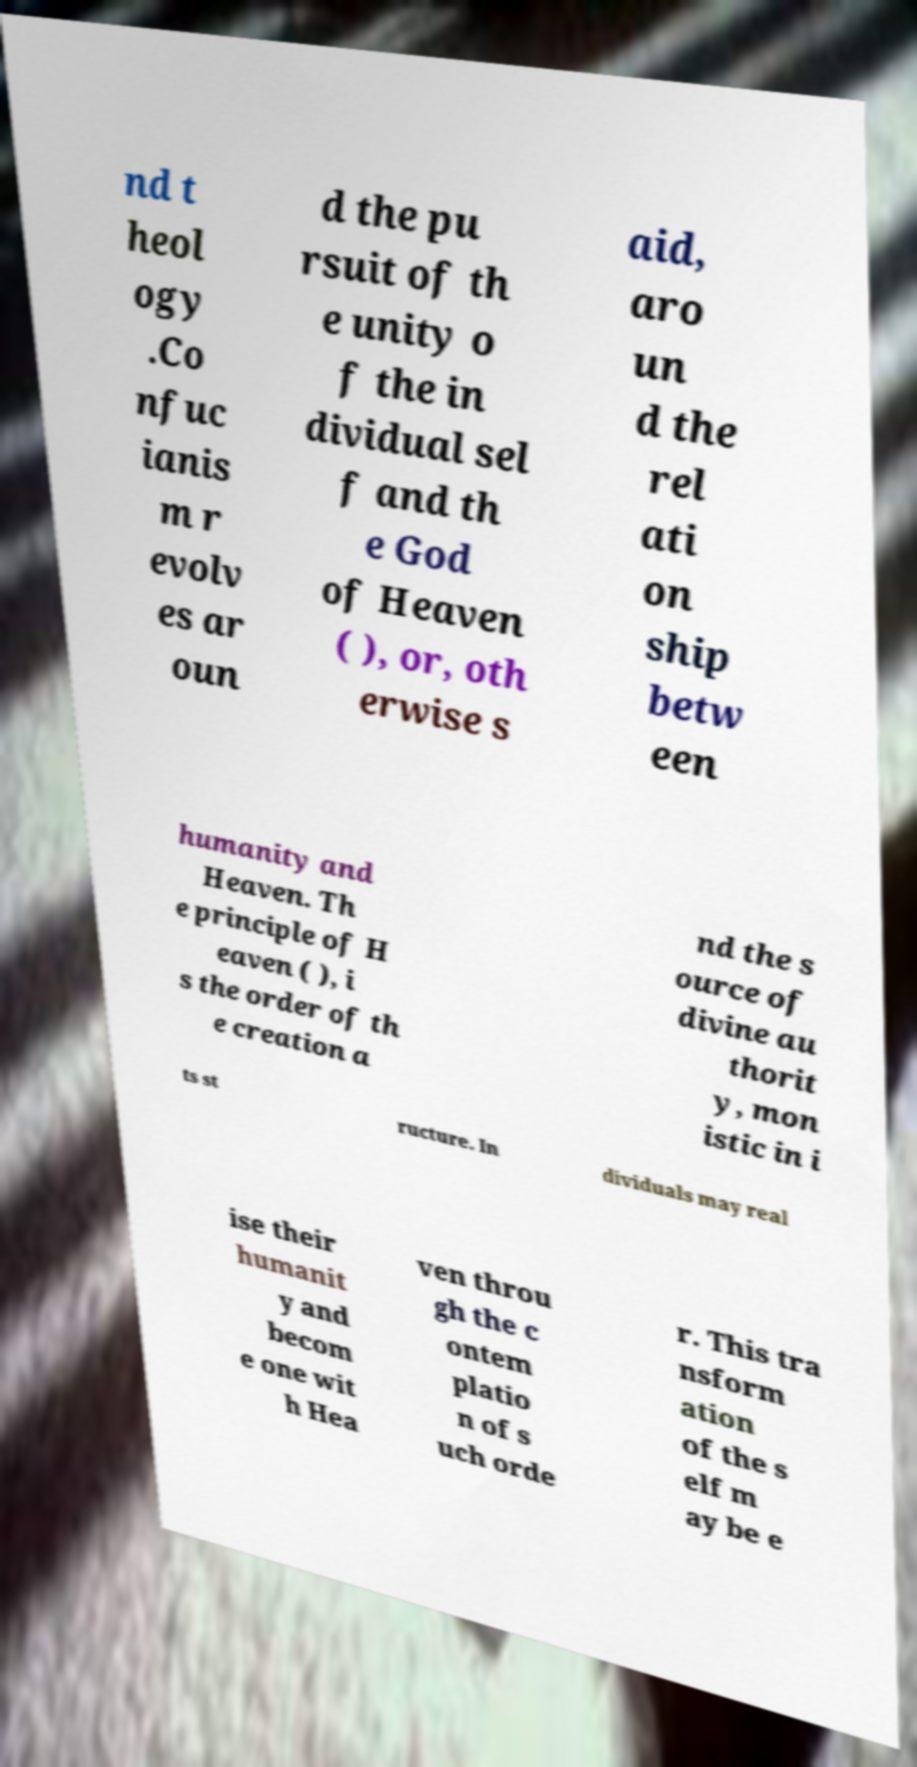Could you extract and type out the text from this image? nd t heol ogy .Co nfuc ianis m r evolv es ar oun d the pu rsuit of th e unity o f the in dividual sel f and th e God of Heaven ( ), or, oth erwise s aid, aro un d the rel ati on ship betw een humanity and Heaven. Th e principle of H eaven ( ), i s the order of th e creation a nd the s ource of divine au thorit y, mon istic in i ts st ructure. In dividuals may real ise their humanit y and becom e one wit h Hea ven throu gh the c ontem platio n of s uch orde r. This tra nsform ation of the s elf m ay be e 